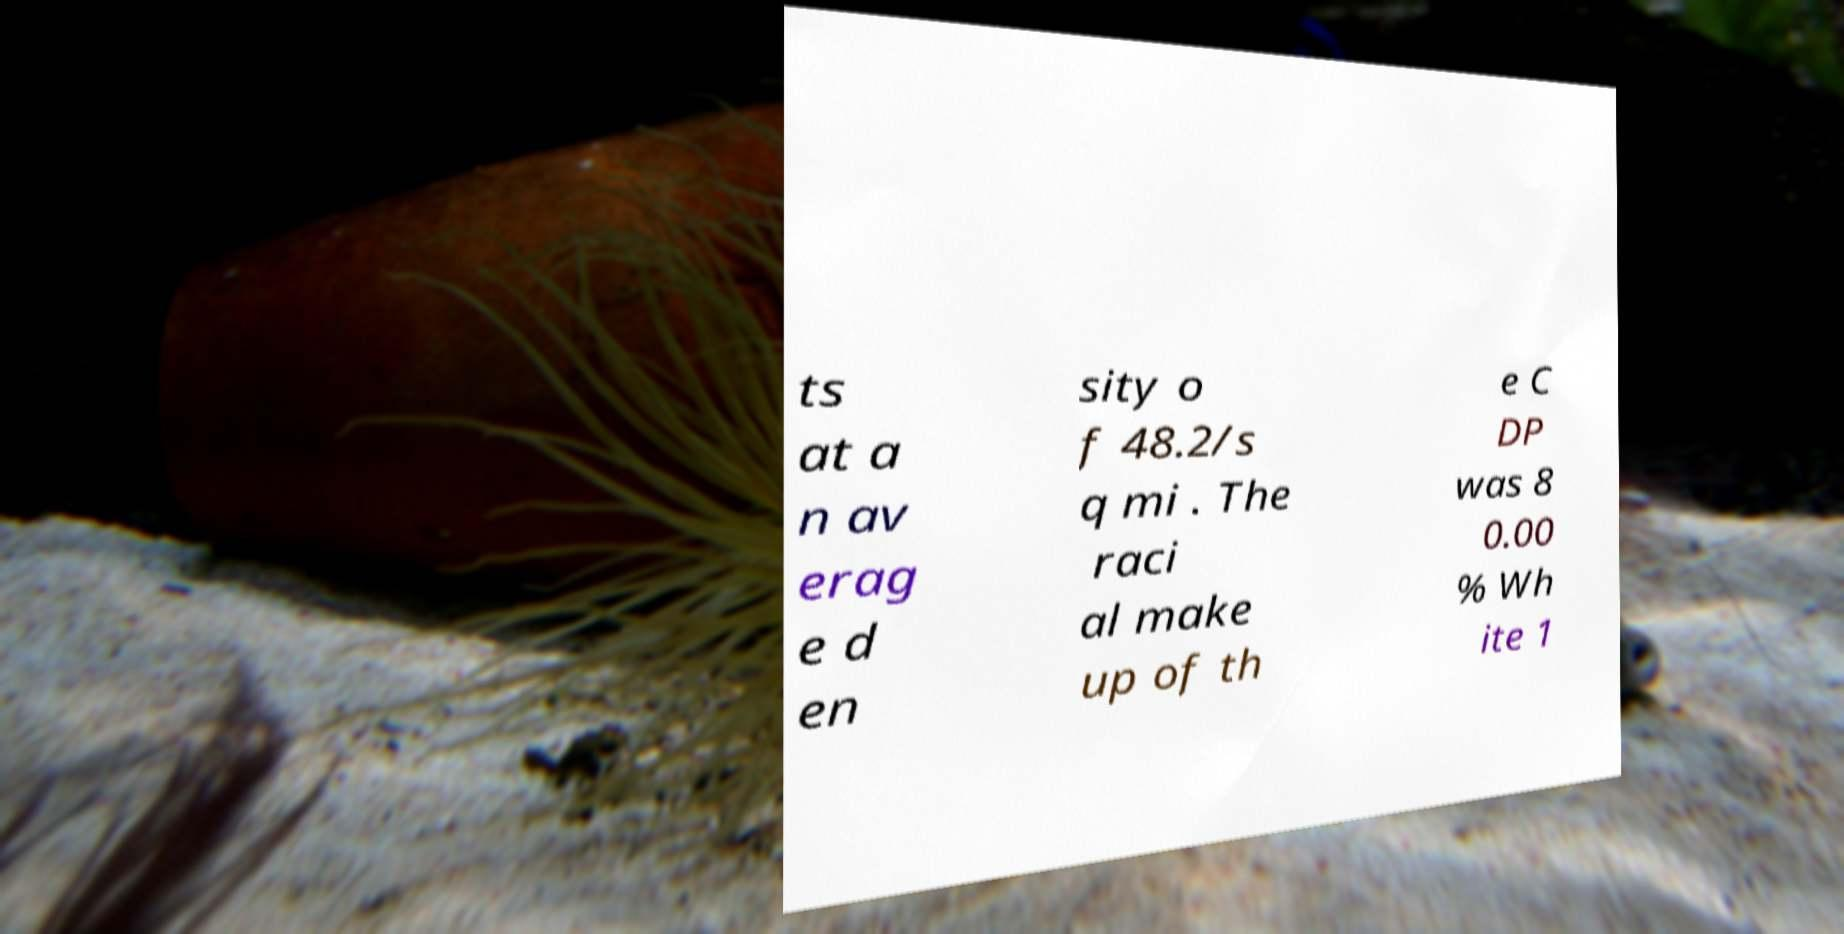Could you extract and type out the text from this image? ts at a n av erag e d en sity o f 48.2/s q mi . The raci al make up of th e C DP was 8 0.00 % Wh ite 1 